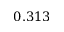<formula> <loc_0><loc_0><loc_500><loc_500>0 . 3 1 3</formula> 